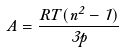Convert formula to latex. <formula><loc_0><loc_0><loc_500><loc_500>A = \frac { R T ( n ^ { 2 } - 1 ) } { 3 p }</formula> 